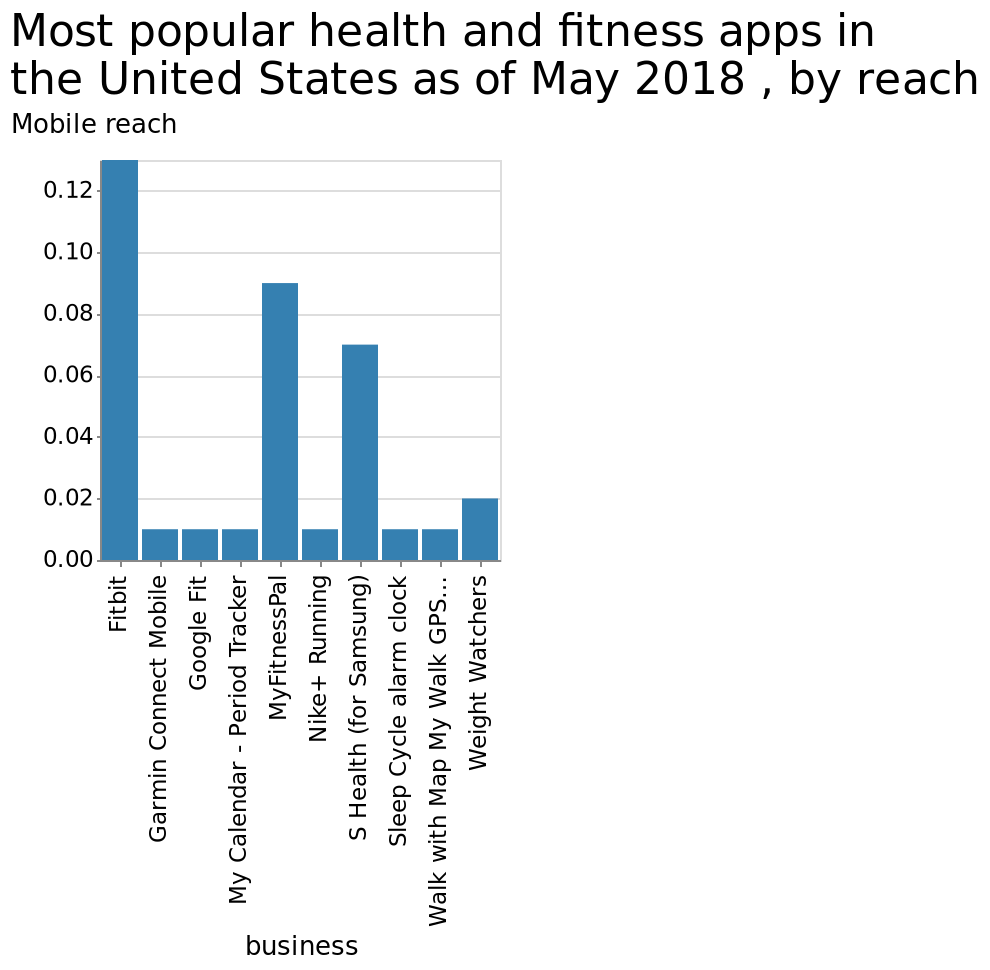<image>
What is the ranking of S Health in terms of mobile reach among fitness apps? S Health is ranked third in terms of mobile reach. How does Fitbit compare to MyFitnessPal and S Health in terms of mobile reach? Fitbit has a significantly larger mobile reach compared to both MyFitnessPal and S Health. What does the y-axis represent in the bar diagram? The y-axis represents the Mobile reach with a linear scale ranging from 0.00 to 0.12. What is the mobile reach ranking of Fitbit compared to other fitness apps? Fitbit has the largest mobile reach overall by a large margin. 